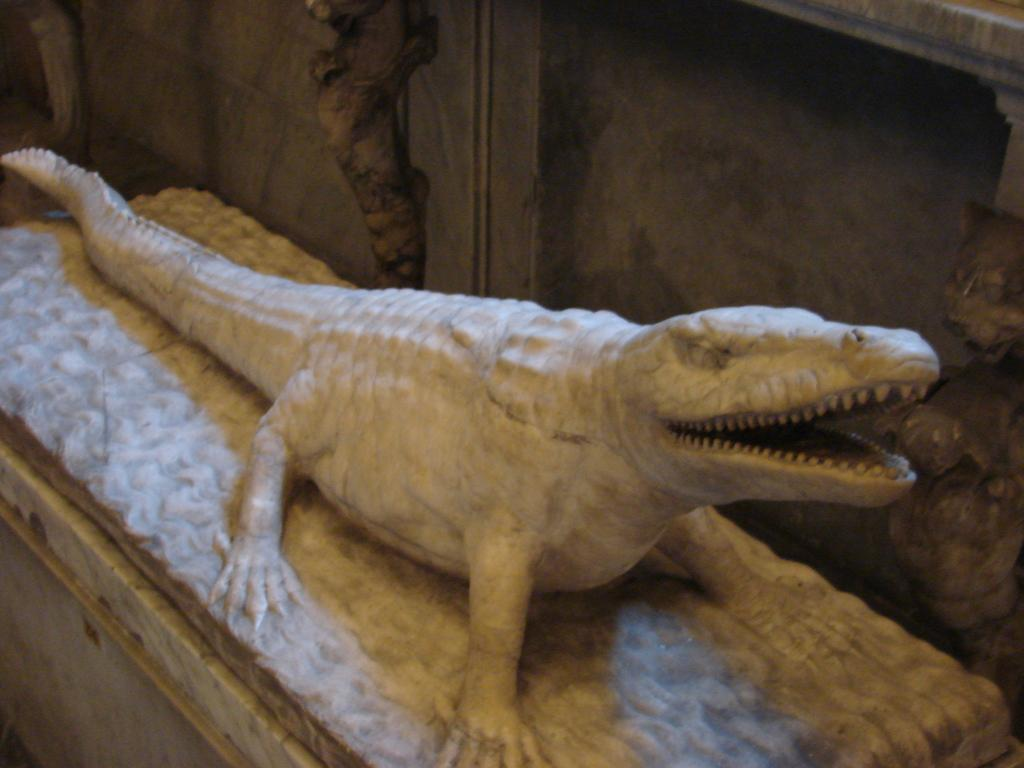What is the main subject of the image? There is a sculpture of a crocodile in the image. Can you describe the background of the image? There is a wall in the background of the image. What type of button is attached to the elbow of the trousers in the image? There are no trousers or buttons present in the image; it features a sculpture of a crocodile and a wall in the background. 